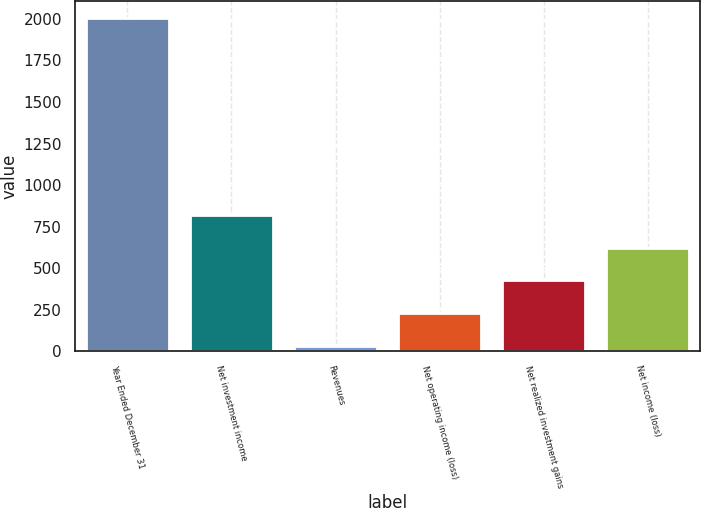Convert chart to OTSL. <chart><loc_0><loc_0><loc_500><loc_500><bar_chart><fcel>Year Ended December 31<fcel>Net investment income<fcel>Revenues<fcel>Net operating income (loss)<fcel>Net realized investment gains<fcel>Net income (loss)<nl><fcel>2008<fcel>821.2<fcel>30<fcel>227.8<fcel>425.6<fcel>623.4<nl></chart> 